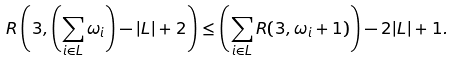<formula> <loc_0><loc_0><loc_500><loc_500>R \left ( 3 , \left ( \sum _ { i \in L } \omega _ { i } \right ) - | L | + 2 \right ) \leq \left ( \sum _ { i \in L } R ( 3 , \omega _ { i } + 1 ) \right ) - 2 | L | + 1 .</formula> 